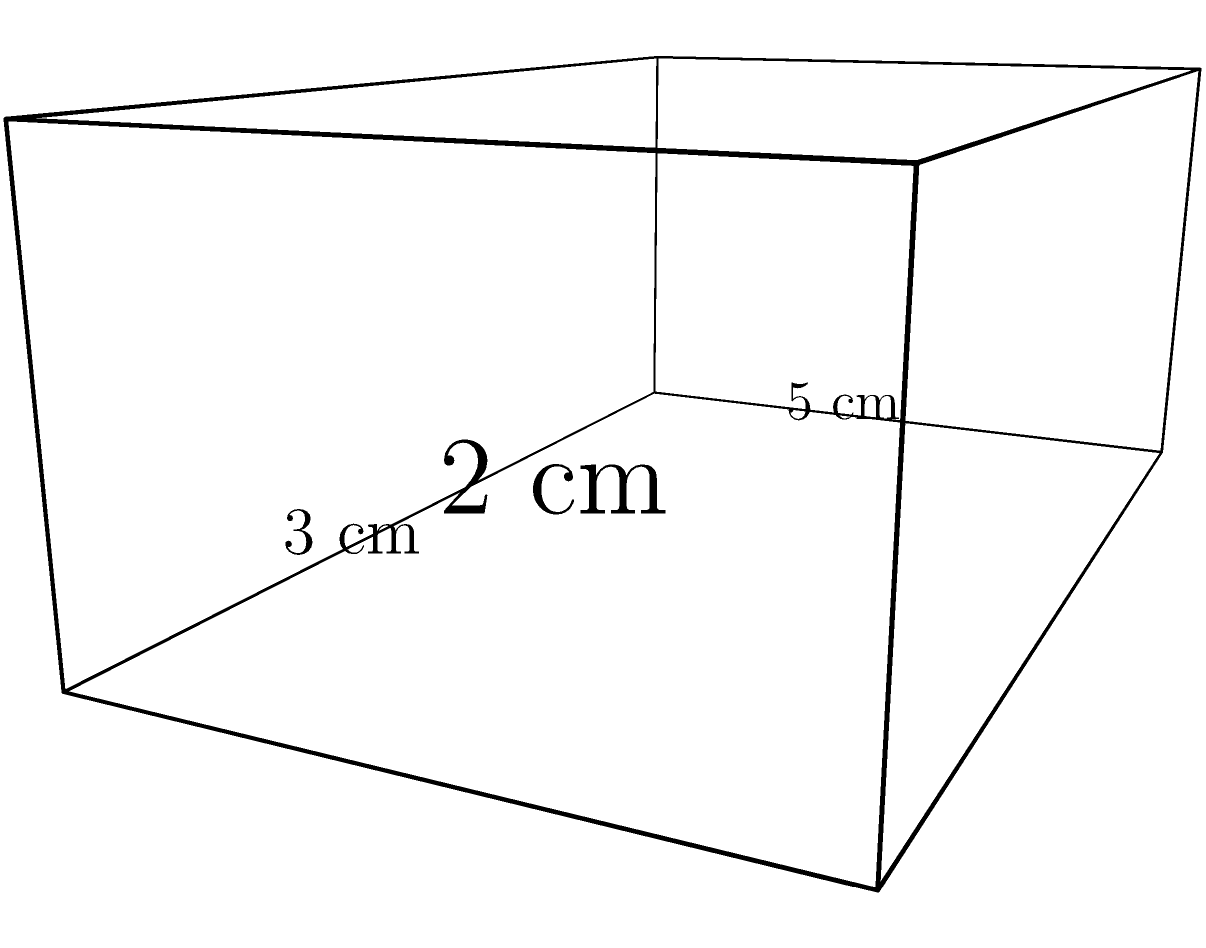In the latest episode of "Passions of Pine Valley," a mysterious gift box arrives at the protagonist's doorstep. The box, rumored to contain a crucial plot device that could change everything, measures 5 cm in length, 3 cm in width, and 2 cm in height. As a dedicated fan theorist, you need to calculate the surface area of this intriguing box. What is the total surface area of the gift box in square centimeters? Let's break this down step-by-step:

1) The box is a rectangular prism with dimensions:
   Length (l) = 5 cm
   Width (w) = 3 cm
   Height (h) = 2 cm

2) The surface area of a rectangular prism is given by the formula:
   $$SA = 2(lw + lh + wh)$$

3) Let's substitute our values:
   $$SA = 2[(5 \times 3) + (5 \times 2) + (3 \times 2)]$$

4) Let's calculate each part:
   $$SA = 2[15 + 10 + 6]$$

5) Sum inside the parentheses:
   $$SA = 2[31]$$

6) Multiply:
   $$SA = 62$$

Therefore, the total surface area of the gift box is 62 square centimeters.
Answer: 62 cm² 